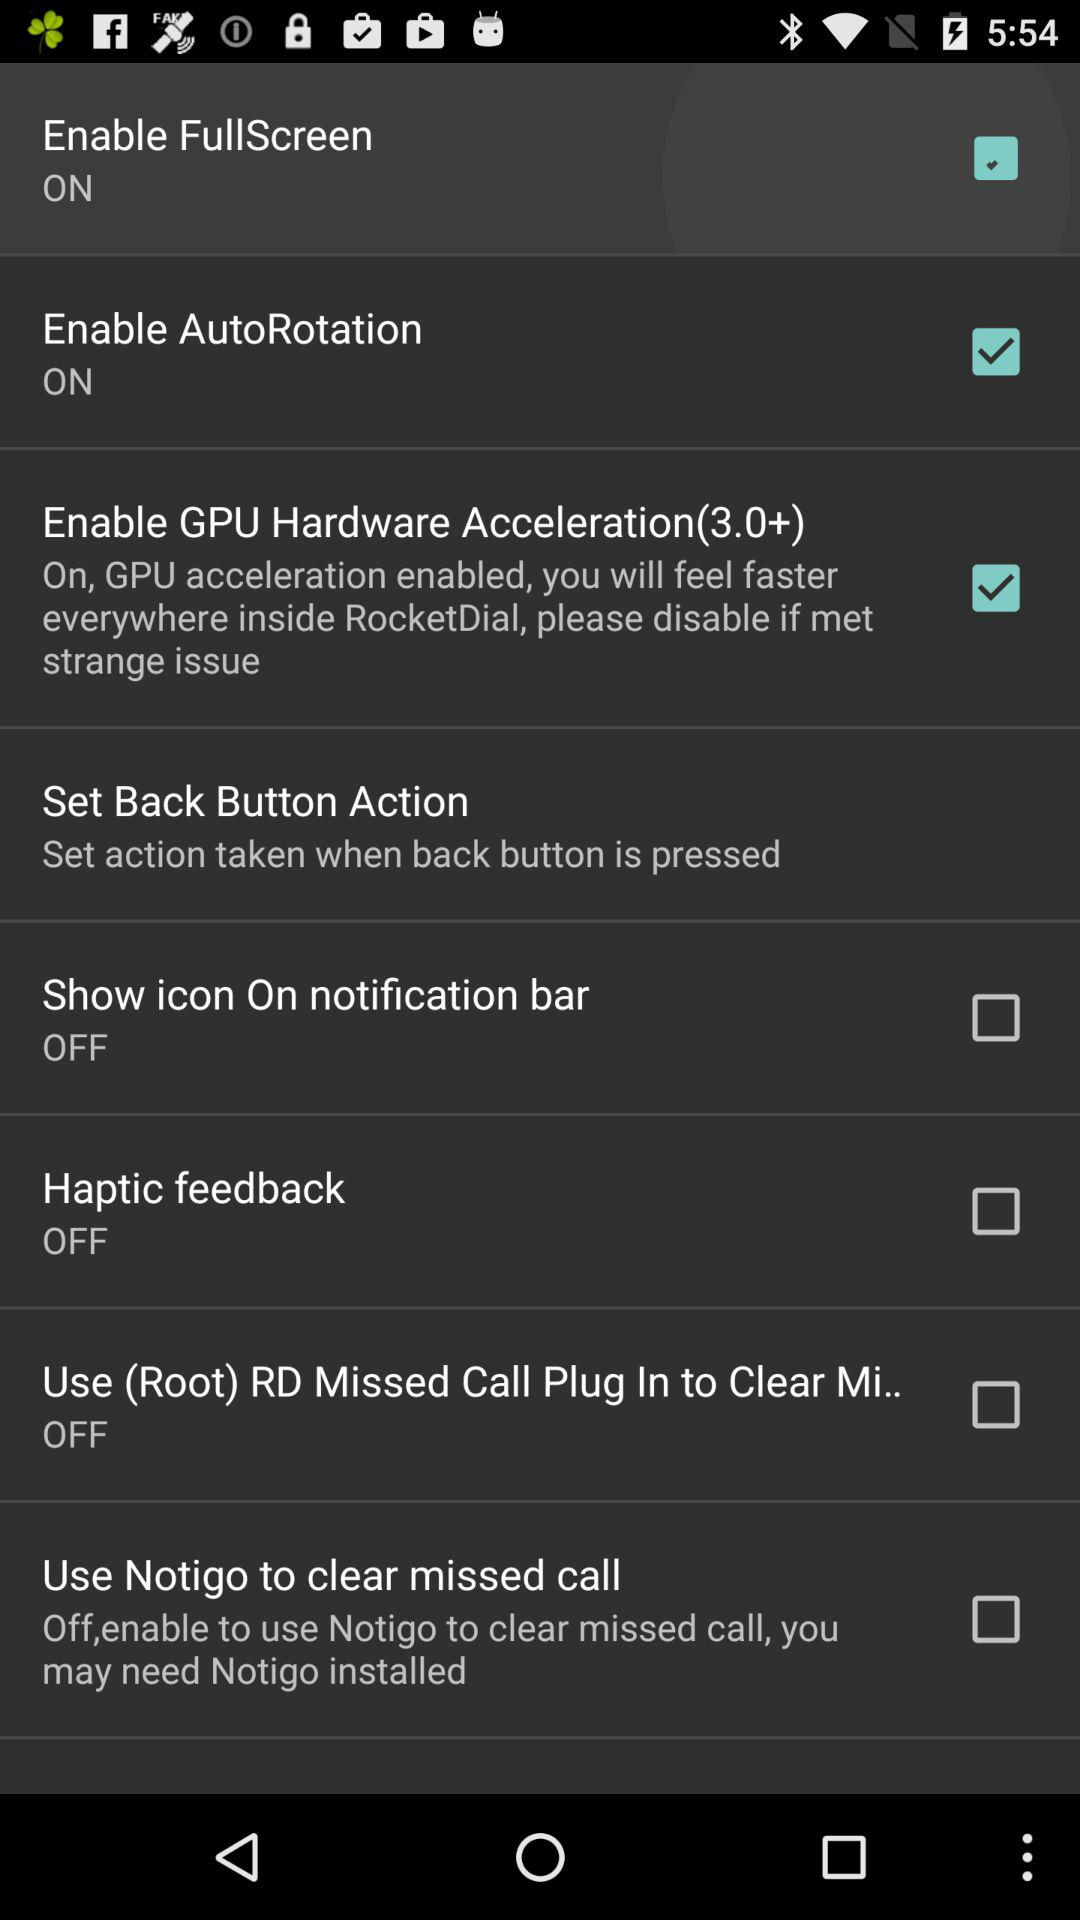What is the status of "Enable GPU Hardware Acceleration(3.0+)"? The status is on. 